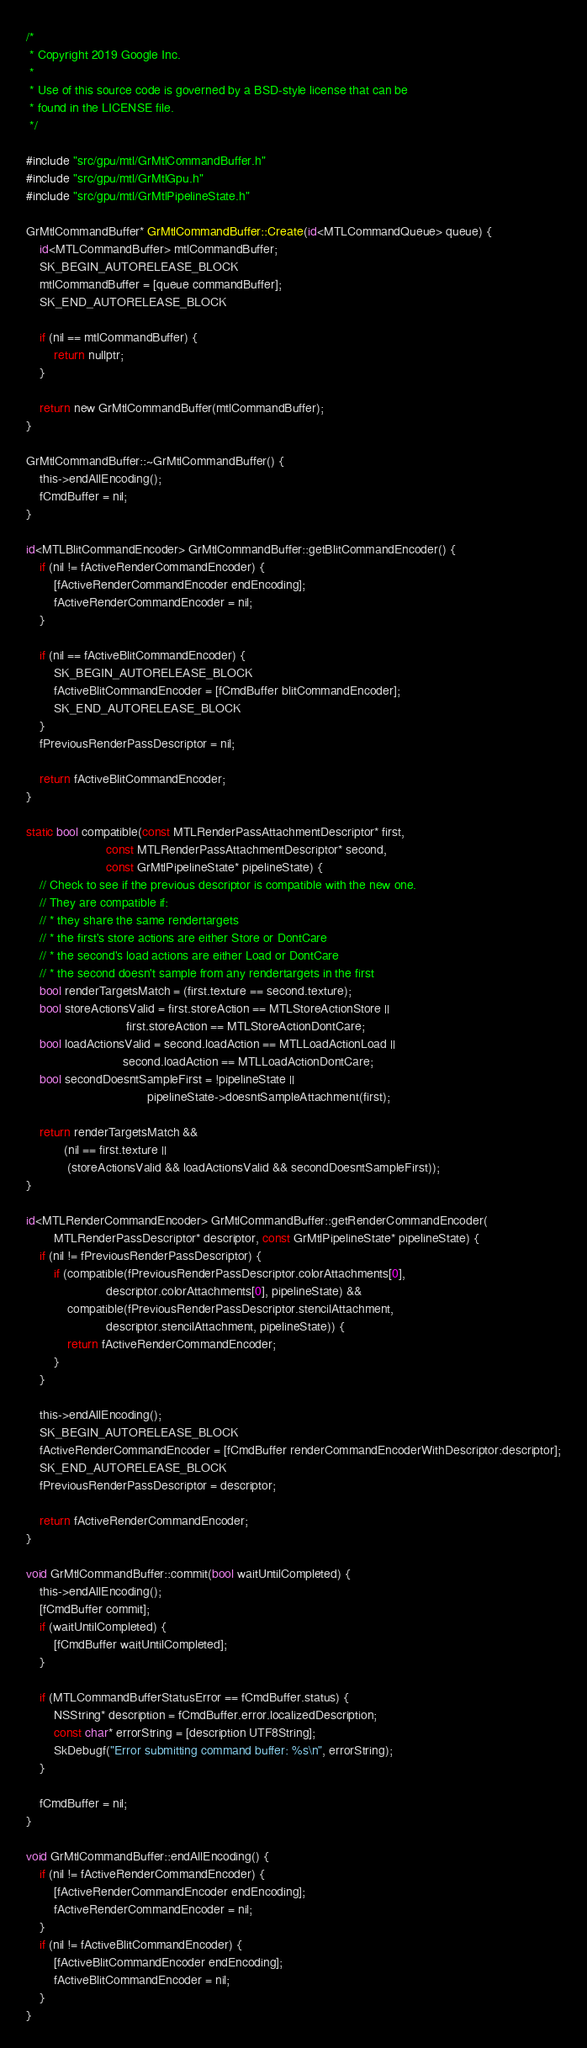<code> <loc_0><loc_0><loc_500><loc_500><_ObjectiveC_>/*
 * Copyright 2019 Google Inc.
 *
 * Use of this source code is governed by a BSD-style license that can be
 * found in the LICENSE file.
 */

#include "src/gpu/mtl/GrMtlCommandBuffer.h"
#include "src/gpu/mtl/GrMtlGpu.h"
#include "src/gpu/mtl/GrMtlPipelineState.h"

GrMtlCommandBuffer* GrMtlCommandBuffer::Create(id<MTLCommandQueue> queue) {
    id<MTLCommandBuffer> mtlCommandBuffer;
    SK_BEGIN_AUTORELEASE_BLOCK
    mtlCommandBuffer = [queue commandBuffer];
    SK_END_AUTORELEASE_BLOCK

    if (nil == mtlCommandBuffer) {
        return nullptr;
    }

    return new GrMtlCommandBuffer(mtlCommandBuffer);
}

GrMtlCommandBuffer::~GrMtlCommandBuffer() {
    this->endAllEncoding();
    fCmdBuffer = nil;
}

id<MTLBlitCommandEncoder> GrMtlCommandBuffer::getBlitCommandEncoder() {
    if (nil != fActiveRenderCommandEncoder) {
        [fActiveRenderCommandEncoder endEncoding];
        fActiveRenderCommandEncoder = nil;
    }

    if (nil == fActiveBlitCommandEncoder) {
        SK_BEGIN_AUTORELEASE_BLOCK
        fActiveBlitCommandEncoder = [fCmdBuffer blitCommandEncoder];
        SK_END_AUTORELEASE_BLOCK
    }
    fPreviousRenderPassDescriptor = nil;

    return fActiveBlitCommandEncoder;
}

static bool compatible(const MTLRenderPassAttachmentDescriptor* first,
                       const MTLRenderPassAttachmentDescriptor* second,
                       const GrMtlPipelineState* pipelineState) {
    // Check to see if the previous descriptor is compatible with the new one.
    // They are compatible if:
    // * they share the same rendertargets
    // * the first's store actions are either Store or DontCare
    // * the second's load actions are either Load or DontCare
    // * the second doesn't sample from any rendertargets in the first
    bool renderTargetsMatch = (first.texture == second.texture);
    bool storeActionsValid = first.storeAction == MTLStoreActionStore ||
                             first.storeAction == MTLStoreActionDontCare;
    bool loadActionsValid = second.loadAction == MTLLoadActionLoad ||
                            second.loadAction == MTLLoadActionDontCare;
    bool secondDoesntSampleFirst = !pipelineState ||
                                   pipelineState->doesntSampleAttachment(first);

    return renderTargetsMatch &&
           (nil == first.texture ||
            (storeActionsValid && loadActionsValid && secondDoesntSampleFirst));
}

id<MTLRenderCommandEncoder> GrMtlCommandBuffer::getRenderCommandEncoder(
        MTLRenderPassDescriptor* descriptor, const GrMtlPipelineState* pipelineState) {
    if (nil != fPreviousRenderPassDescriptor) {
        if (compatible(fPreviousRenderPassDescriptor.colorAttachments[0],
                       descriptor.colorAttachments[0], pipelineState) &&
            compatible(fPreviousRenderPassDescriptor.stencilAttachment,
                       descriptor.stencilAttachment, pipelineState)) {
            return fActiveRenderCommandEncoder;
        }
    }

    this->endAllEncoding();
    SK_BEGIN_AUTORELEASE_BLOCK
    fActiveRenderCommandEncoder = [fCmdBuffer renderCommandEncoderWithDescriptor:descriptor];
    SK_END_AUTORELEASE_BLOCK
    fPreviousRenderPassDescriptor = descriptor;

    return fActiveRenderCommandEncoder;
}

void GrMtlCommandBuffer::commit(bool waitUntilCompleted) {
    this->endAllEncoding();
    [fCmdBuffer commit];
    if (waitUntilCompleted) {
        [fCmdBuffer waitUntilCompleted];
    }

    if (MTLCommandBufferStatusError == fCmdBuffer.status) {
        NSString* description = fCmdBuffer.error.localizedDescription;
        const char* errorString = [description UTF8String];
        SkDebugf("Error submitting command buffer: %s\n", errorString);
    }

    fCmdBuffer = nil;
}

void GrMtlCommandBuffer::endAllEncoding() {
    if (nil != fActiveRenderCommandEncoder) {
        [fActiveRenderCommandEncoder endEncoding];
        fActiveRenderCommandEncoder = nil;
    }
    if (nil != fActiveBlitCommandEncoder) {
        [fActiveBlitCommandEncoder endEncoding];
        fActiveBlitCommandEncoder = nil;
    }
}
</code> 